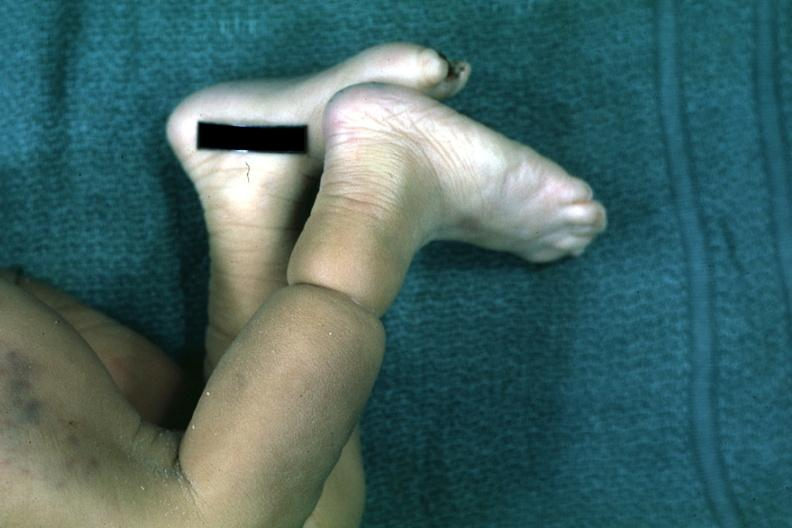s foot present?
Answer the question using a single word or phrase. Yes 